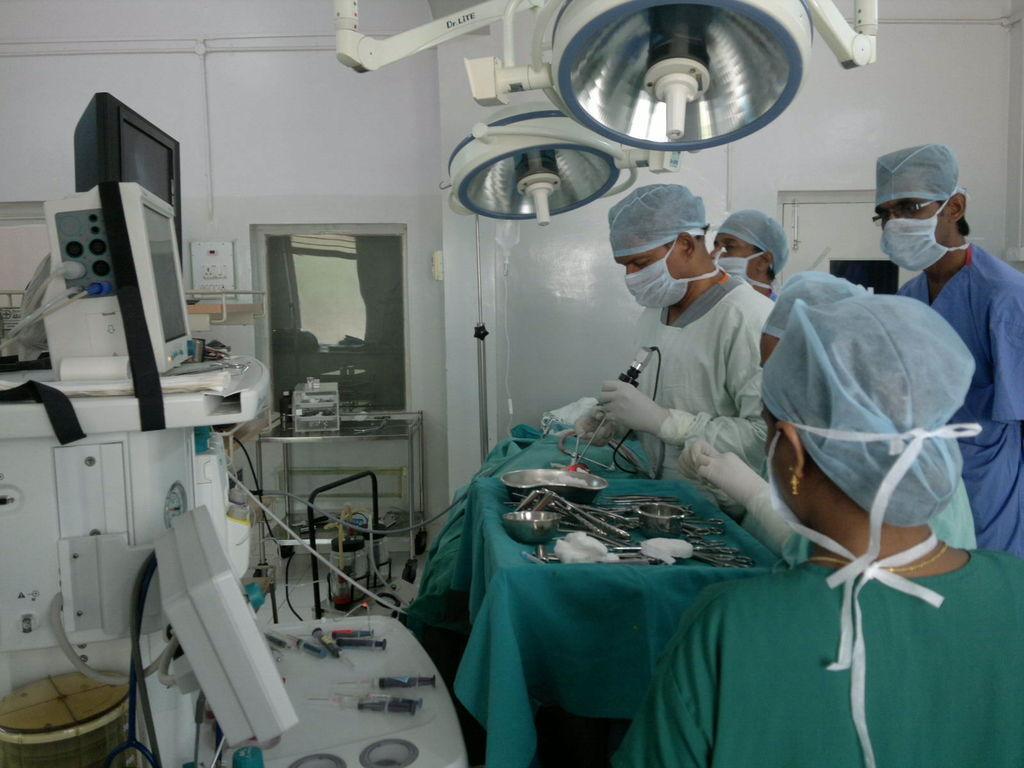Describe this image in one or two sentences. I n the image it is an operation theater, the doctors are preparing the surgery equipment and on a table there are many scissors and some other tools, beside the table there are different machines and above the table there are two operation lights, there are total five people inside the room, in the background there is a white wall and beside the wall there is a door. 